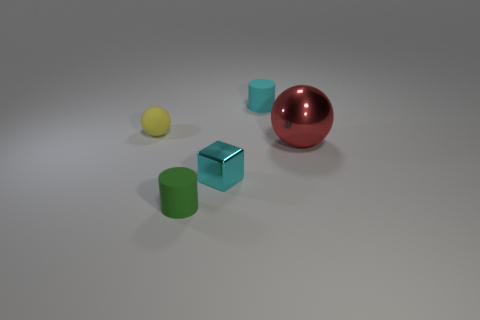What shape is the thing that is the same color as the cube?
Make the answer very short. Cylinder. There is a rubber object that is the same color as the small metallic thing; what is its size?
Your answer should be compact. Small. Is the green matte cylinder the same size as the red thing?
Your response must be concise. No. There is a small cylinder that is behind the small yellow matte object; is its color the same as the shiny block?
Keep it short and to the point. Yes. There is a small yellow matte thing; what number of yellow spheres are behind it?
Your answer should be very brief. 0. Are there more large red metal things than big brown balls?
Your answer should be compact. Yes. The small thing that is on the left side of the small cyan cube and in front of the yellow thing has what shape?
Offer a terse response. Cylinder. Are any tiny green objects visible?
Keep it short and to the point. Yes. There is a yellow thing that is the same shape as the large red metallic thing; what material is it?
Your answer should be compact. Rubber. What shape is the cyan thing in front of the rubber object that is left of the small cylinder that is in front of the metallic cube?
Offer a terse response. Cube. 